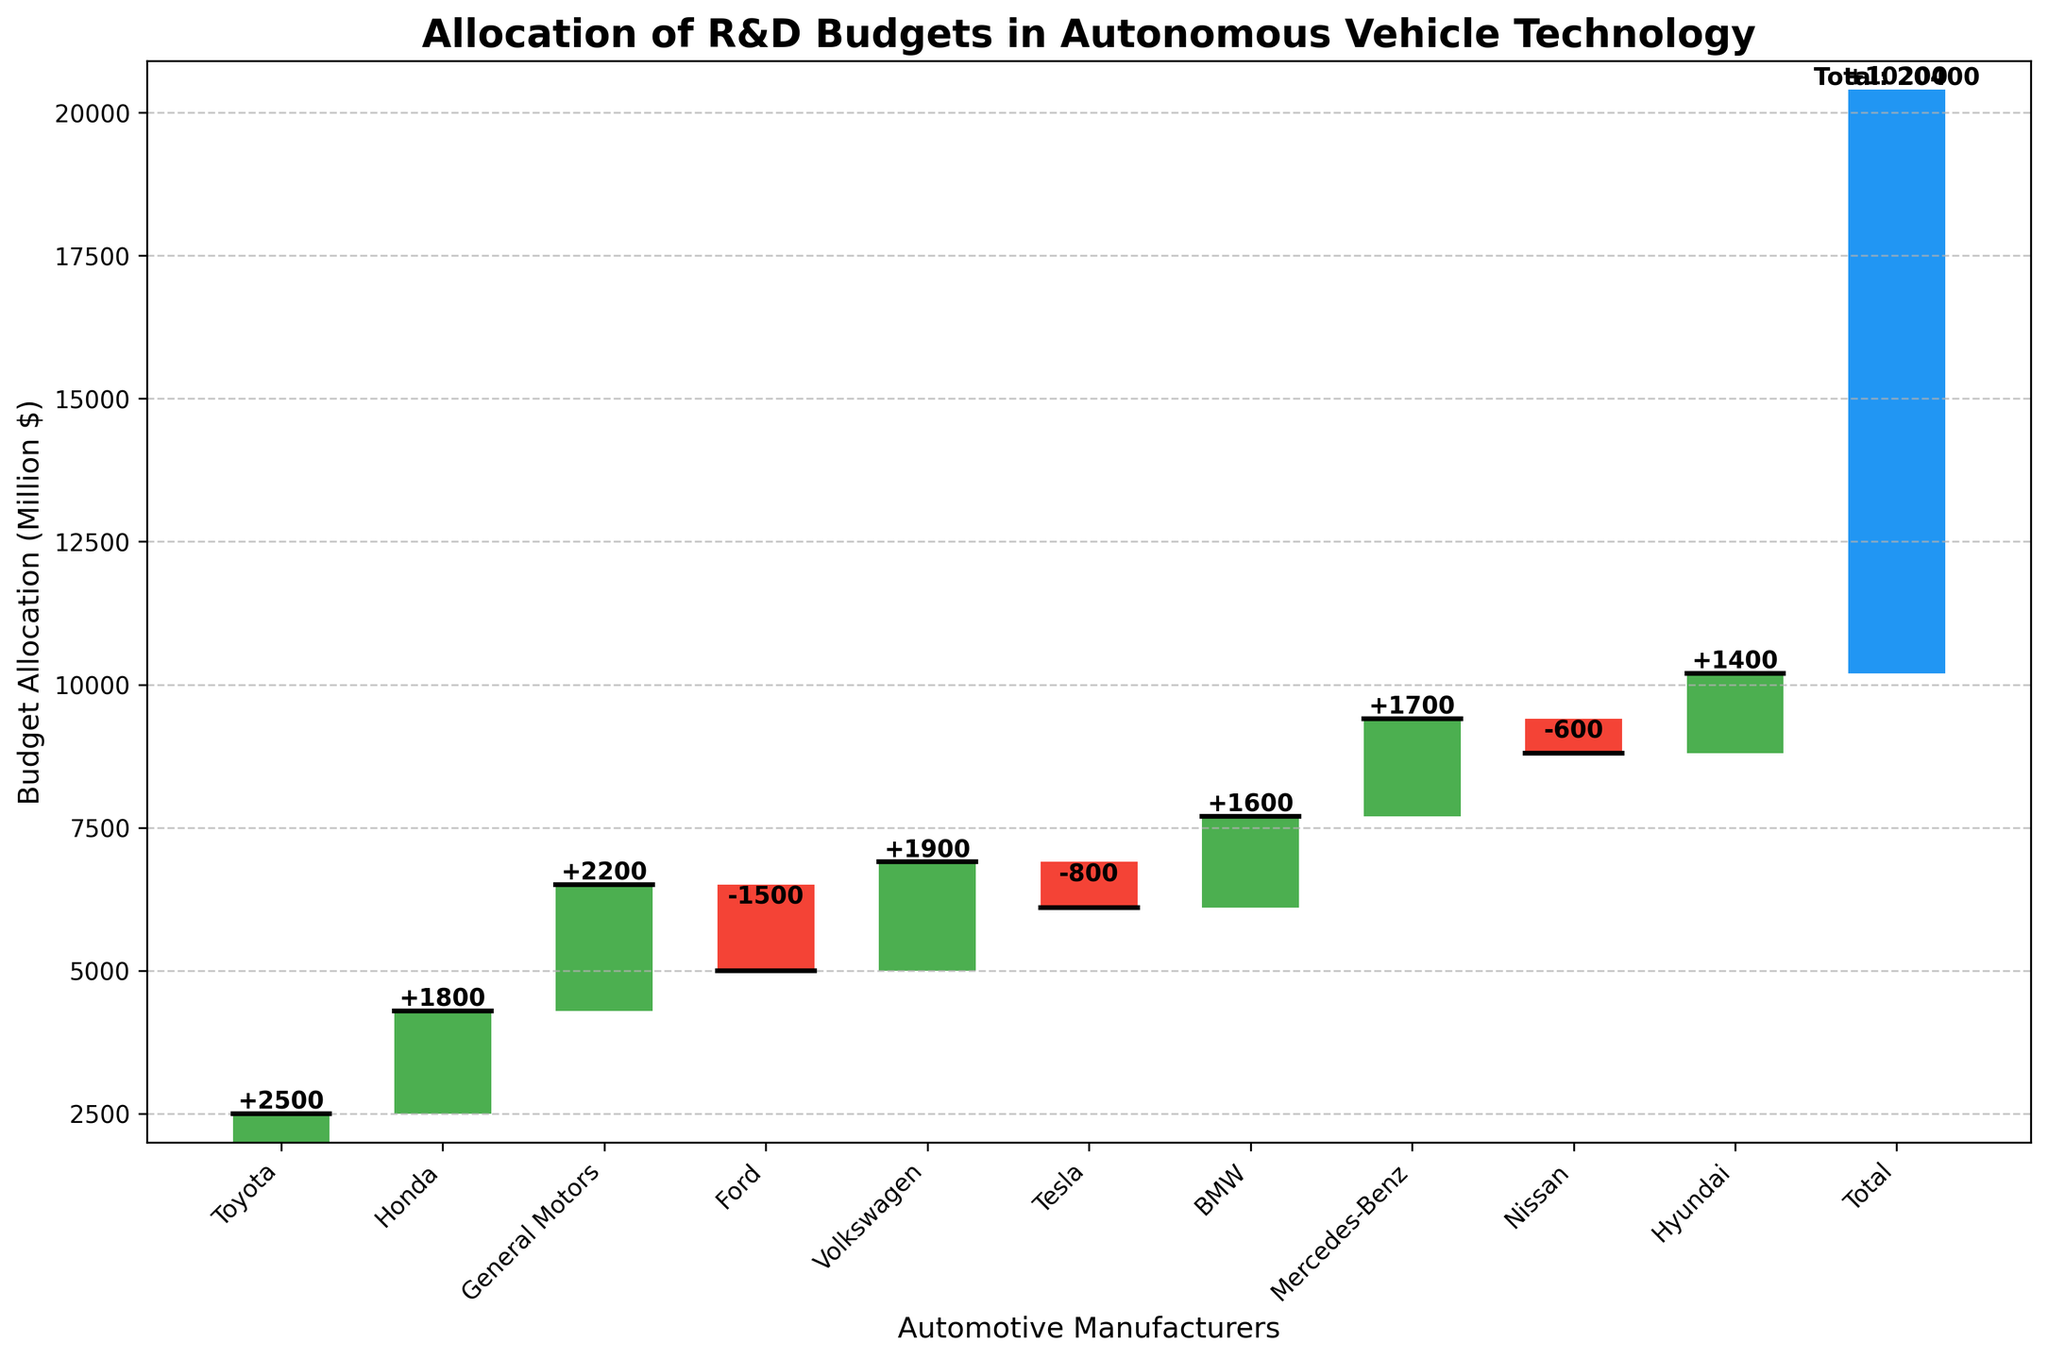What is the title of the figure? The title is usually displayed at the top of the chart. In this case, it should be clearly stated at the top.
Answer: Allocation of R&D Budgets in Autonomous Vehicle Technology Which manufacturer has the highest budget allocation and what is the value? By looking for the tallest positive bar, you can identify the manufacturer with the highest budget allocation. In this case, it's Toyota.
Answer: Toyota, 2500 million $ How many manufacturers have a negative budget allocation, and who are they? By identifying the number of bars that fall below the horizontal axis and reading their labels, you can count the manufacturers with negative allocations.
Answer: 3 manufacturers: Ford, Tesla, Nissan What is the total R&D budget allocation for autonomous vehicle technology? The total is indicated by the last bar labeled "Total" at the end of the waterfall chart.
Answer: 10200 million $ What is the budget difference between Toyota and General Motors? Subtract the value of General Motors from the value of Toyota: 2500 - 2200 = 300.
Answer: 300 million $ How many manufacturers are included in the waterfall chart besides the total? Count the number of category labels excluding the 'Total'.
Answer: 10 manufacturers Which manufacturers have budget allocations greater than 1900 million $? Identify and name all bars with values exceeding 1900 million $.
Answer: Toyota (2500), General Motors (2200) What is the combined budget allocation of Honda, Volkswagen, and Hyundai? Sum the values of Honda (1800), Volkswagen (1900), and Hyundai (1400): 1800 + 1900 + 1400 = 5100.
Answer: 5100 million $ Which manufacturer has the smallest budget allocation and what is the value? Identify the bar with the least value to find the manufacturer with the smallest allocation.
Answer: Ford, -1500 million $ What color is used to represent positive budget allocations in the chart? Identify the color of the bars representing positive values by observing the color code.
Answer: Green 